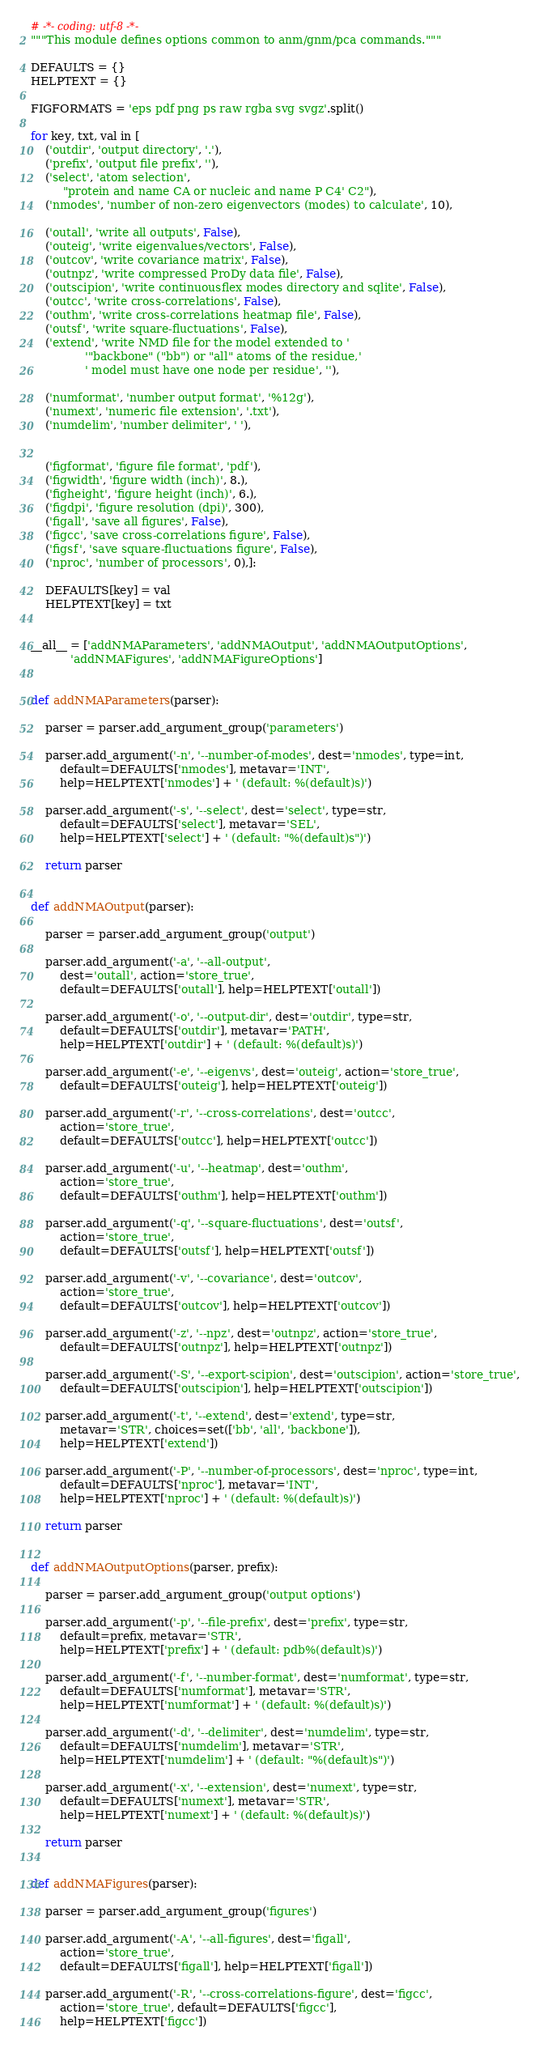<code> <loc_0><loc_0><loc_500><loc_500><_Python_># -*- coding: utf-8 -*-
"""This module defines options common to anm/gnm/pca commands."""

DEFAULTS = {}
HELPTEXT = {}

FIGFORMATS = 'eps pdf png ps raw rgba svg svgz'.split()

for key, txt, val in [
    ('outdir', 'output directory', '.'),
    ('prefix', 'output file prefix', ''),
    ('select', 'atom selection',
         "protein and name CA or nucleic and name P C4' C2"),
    ('nmodes', 'number of non-zero eigenvectors (modes) to calculate', 10),

    ('outall', 'write all outputs', False),
    ('outeig', 'write eigenvalues/vectors', False),
    ('outcov', 'write covariance matrix', False),
    ('outnpz', 'write compressed ProDy data file', False),
    ('outscipion', 'write continuousflex modes directory and sqlite', False),
    ('outcc', 'write cross-correlations', False),
    ('outhm', 'write cross-correlations heatmap file', False),
    ('outsf', 'write square-fluctuations', False),
    ('extend', 'write NMD file for the model extended to '
               '"backbone" ("bb") or "all" atoms of the residue,'
               ' model must have one node per residue', ''),

    ('numformat', 'number output format', '%12g'),
    ('numext', 'numeric file extension', '.txt'),
    ('numdelim', 'number delimiter', ' '),


    ('figformat', 'figure file format', 'pdf'),
    ('figwidth', 'figure width (inch)', 8.),
    ('figheight', 'figure height (inch)', 6.),
    ('figdpi', 'figure resolution (dpi)', 300),
    ('figall', 'save all figures', False),
    ('figcc', 'save cross-correlations figure', False),
    ('figsf', 'save square-fluctuations figure', False),
    ('nproc', 'number of processors', 0),]:

    DEFAULTS[key] = val
    HELPTEXT[key] = txt


__all__ = ['addNMAParameters', 'addNMAOutput', 'addNMAOutputOptions',
           'addNMAFigures', 'addNMAFigureOptions']


def addNMAParameters(parser):

    parser = parser.add_argument_group('parameters')

    parser.add_argument('-n', '--number-of-modes', dest='nmodes', type=int,
        default=DEFAULTS['nmodes'], metavar='INT',
        help=HELPTEXT['nmodes'] + ' (default: %(default)s)')

    parser.add_argument('-s', '--select', dest='select', type=str,
        default=DEFAULTS['select'], metavar='SEL',
        help=HELPTEXT['select'] + ' (default: "%(default)s")')

    return parser


def addNMAOutput(parser):

    parser = parser.add_argument_group('output')

    parser.add_argument('-a', '--all-output',
        dest='outall', action='store_true',
        default=DEFAULTS['outall'], help=HELPTEXT['outall'])

    parser.add_argument('-o', '--output-dir', dest='outdir', type=str,
        default=DEFAULTS['outdir'], metavar='PATH',
        help=HELPTEXT['outdir'] + ' (default: %(default)s)')

    parser.add_argument('-e', '--eigenvs', dest='outeig', action='store_true',
        default=DEFAULTS['outeig'], help=HELPTEXT['outeig'])

    parser.add_argument('-r', '--cross-correlations', dest='outcc',
        action='store_true',
        default=DEFAULTS['outcc'], help=HELPTEXT['outcc'])

    parser.add_argument('-u', '--heatmap', dest='outhm',
        action='store_true',
        default=DEFAULTS['outhm'], help=HELPTEXT['outhm'])

    parser.add_argument('-q', '--square-fluctuations', dest='outsf',
        action='store_true',
        default=DEFAULTS['outsf'], help=HELPTEXT['outsf'])

    parser.add_argument('-v', '--covariance', dest='outcov',
        action='store_true',
        default=DEFAULTS['outcov'], help=HELPTEXT['outcov'])

    parser.add_argument('-z', '--npz', dest='outnpz', action='store_true',
        default=DEFAULTS['outnpz'], help=HELPTEXT['outnpz'])

    parser.add_argument('-S', '--export-scipion', dest='outscipion', action='store_true',
        default=DEFAULTS['outscipion'], help=HELPTEXT['outscipion'])

    parser.add_argument('-t', '--extend', dest='extend', type=str,
        metavar='STR', choices=set(['bb', 'all', 'backbone']),
        help=HELPTEXT['extend'])

    parser.add_argument('-P', '--number-of-processors', dest='nproc', type=int,
        default=DEFAULTS['nproc'], metavar='INT',
        help=HELPTEXT['nproc'] + ' (default: %(default)s)')        

    return parser


def addNMAOutputOptions(parser, prefix):

    parser = parser.add_argument_group('output options')

    parser.add_argument('-p', '--file-prefix', dest='prefix', type=str,
        default=prefix, metavar='STR',
        help=HELPTEXT['prefix'] + ' (default: pdb%(default)s)')

    parser.add_argument('-f', '--number-format', dest='numformat', type=str,
        default=DEFAULTS['numformat'], metavar='STR',
        help=HELPTEXT['numformat'] + ' (default: %(default)s)')

    parser.add_argument('-d', '--delimiter', dest='numdelim', type=str,
        default=DEFAULTS['numdelim'], metavar='STR',
        help=HELPTEXT['numdelim'] + ' (default: "%(default)s")')

    parser.add_argument('-x', '--extension', dest='numext', type=str,
        default=DEFAULTS['numext'], metavar='STR',
        help=HELPTEXT['numext'] + ' (default: %(default)s)')

    return parser


def addNMAFigures(parser):

    parser = parser.add_argument_group('figures')

    parser.add_argument('-A', '--all-figures', dest='figall',
        action='store_true',
        default=DEFAULTS['figall'], help=HELPTEXT['figall'])

    parser.add_argument('-R', '--cross-correlations-figure', dest='figcc',
        action='store_true', default=DEFAULTS['figcc'],
        help=HELPTEXT['figcc'])
</code> 